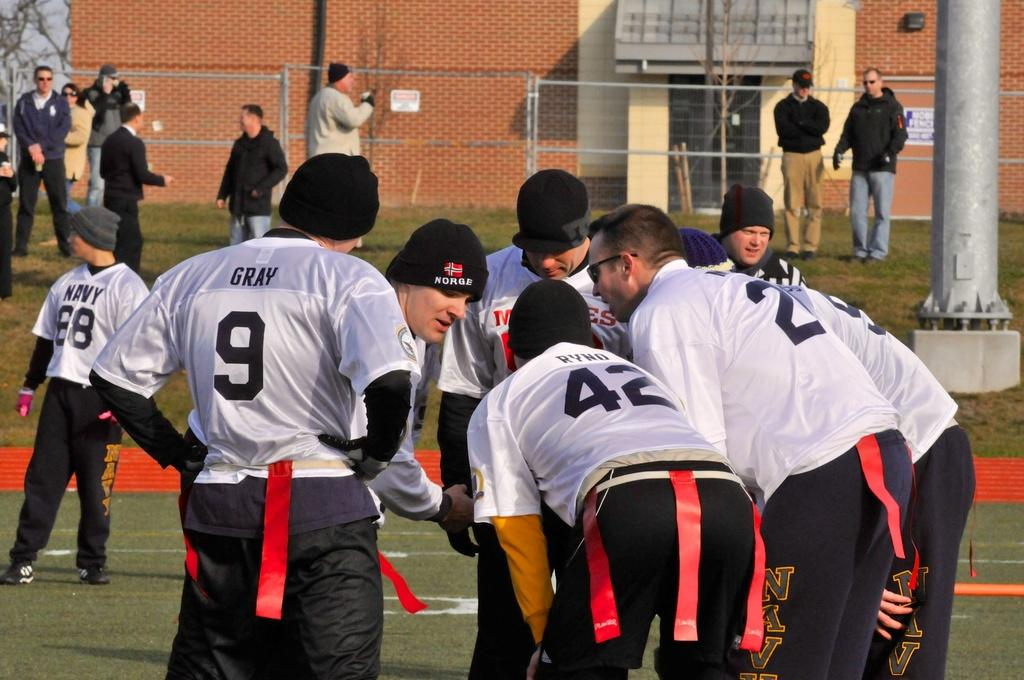<image>
Write a terse but informative summary of the picture. A group of athletes, one of who has the number 9 on their shirt. 